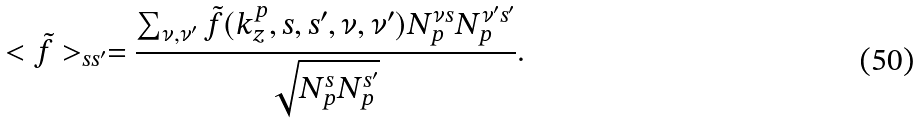Convert formula to latex. <formula><loc_0><loc_0><loc_500><loc_500>< { \tilde { f } } > _ { s s ^ { \prime } } = \frac { \sum _ { \nu , \nu ^ { \prime } } \tilde { f } ( k ^ { p } _ { z } , s , s ^ { \prime } , \nu , \nu ^ { \prime } ) N ^ { \nu s } _ { p } N ^ { \nu ^ { \prime } s ^ { \prime } } _ { p } } { \sqrt { N ^ { s } _ { p } N ^ { s ^ { \prime } } _ { p } } } .</formula> 